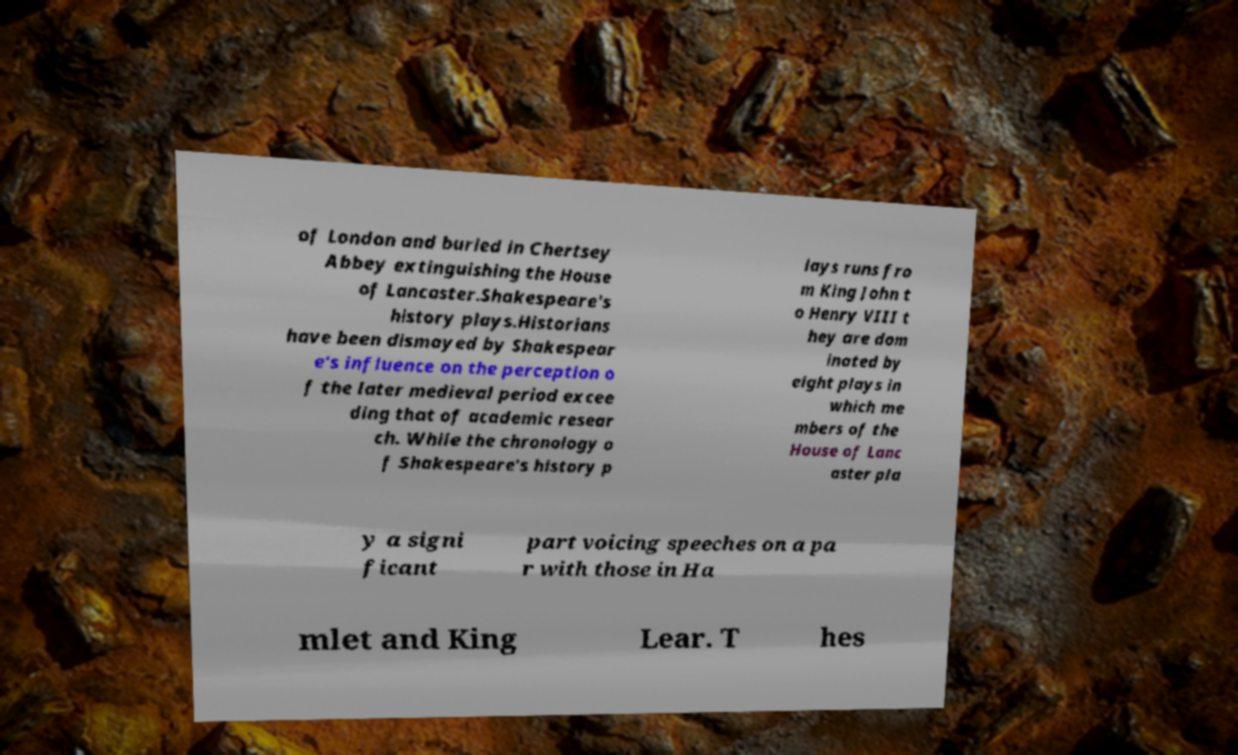For documentation purposes, I need the text within this image transcribed. Could you provide that? of London and buried in Chertsey Abbey extinguishing the House of Lancaster.Shakespeare's history plays.Historians have been dismayed by Shakespear e's influence on the perception o f the later medieval period excee ding that of academic resear ch. While the chronology o f Shakespeare's history p lays runs fro m King John t o Henry VIII t hey are dom inated by eight plays in which me mbers of the House of Lanc aster pla y a signi ficant part voicing speeches on a pa r with those in Ha mlet and King Lear. T hes 